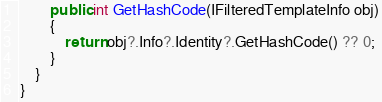<code> <loc_0><loc_0><loc_500><loc_500><_C#_>
        public int GetHashCode(IFilteredTemplateInfo obj)
        {
            return obj?.Info?.Identity?.GetHashCode() ?? 0;
        }
    }
}</code> 